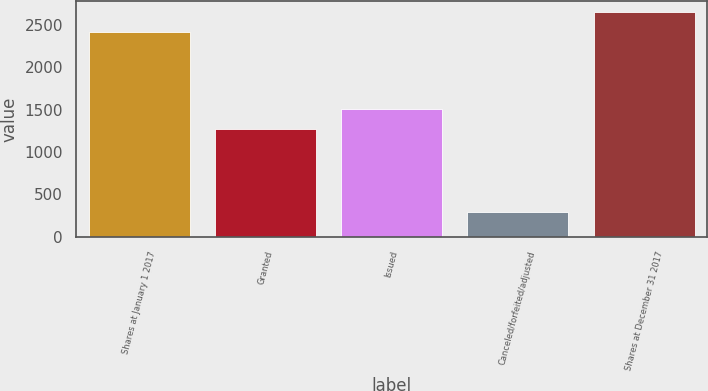<chart> <loc_0><loc_0><loc_500><loc_500><bar_chart><fcel>Shares at January 1 2017<fcel>Granted<fcel>Issued<fcel>Canceled/forfeited/adjusted<fcel>Shares at December 31 2017<nl><fcel>2415<fcel>1276<fcel>1509<fcel>295<fcel>2648<nl></chart> 